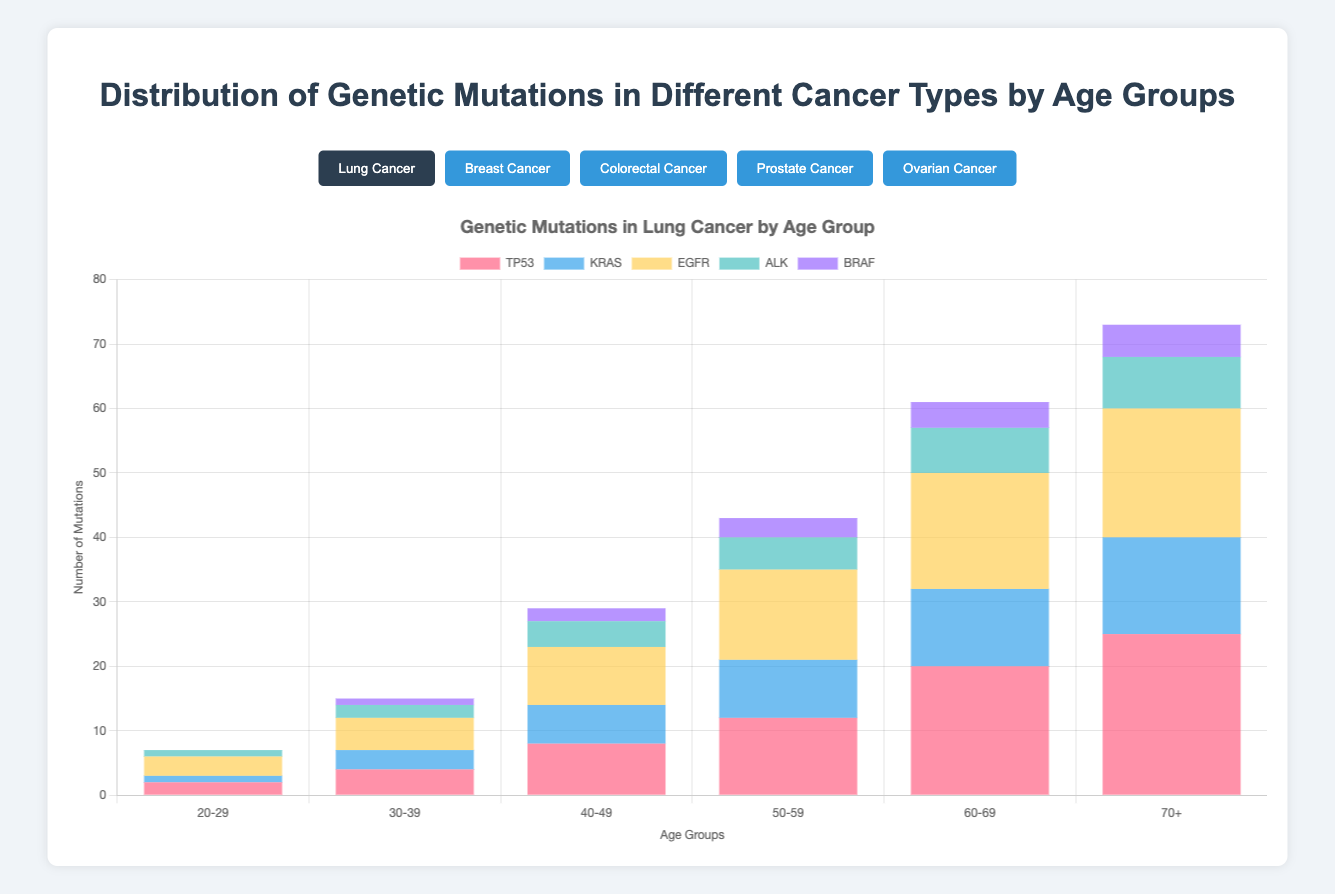Which age group experiences the highest number of TP53 mutations in Lung Cancer? Look at the stacked bar chart for Lung Cancer and identify the age group with the tallest section representing TP53 mutations. The "70+" age group has the highest section for TP53.
Answer: 70+ Which genetic mutation is least common in Breast Cancer for the 20-29 age group? Examine the stacked bar for the 20-29 age group in Breast Cancer. The smallest section in the bar is for PTEN with only 1 mutation.
Answer: PTEN Comparing KRAS mutations in Lung Cancer, which age group has a greater count: 60-69 or 50-59? Check the heights of the KRAS mutation parts of the bars for both the 60-69 and 50-59 age groups in Lung Cancer. The 60-69 age group has a higher count with 12 mutations compared to 9 in the 50-59 age group.
Answer: 60-69 What is the total number of BRCA1 mutations across all age groups in Ovarian Cancer? Sum up the BRCA1 values across all age groups in Ovarian Cancer: 5 + 8 + 11 + 15 + 18 + 20 = 77.
Answer: 77 Which cancer type shows the highest number of TP53 mutations in the 60-69 age group? Compare the TP53 sections of the 60-69 bars across all cancer types. Lung Cancer has 20, Breast Cancer has 8, Colorectal Cancer has 16, Prostate Cancer has 12, and Ovarian Cancer has 12. Lung Cancer shows the highest with 20 mutations.
Answer: Lung Cancer How do the total number of mutations for the 50-59 age group compare between Prostate Cancer and Colorectal Cancer? Sum the mutation counts for Prostate Cancer and Colorectal Cancer in the 50-59 age group. Prostate Cancer has 9 + 5 + 3 + 3 + 2 = 22, and Colorectal Cancer has 14 + 10 + 12 + 6 + 3 = 45.
Answer: Colorectal Cancer has more What is the average number of mutations for PIK3CA in the 30-39 age group across all cancer types? Find the PIK3CA counts for each cancer type in the 30-39 age group, then calculate the average: [Lung Cancer: 0 + Breast Cancer: 3 + Colorectal Cancer: 1 + Prostate Cancer: 0 + Ovarian Cancer: 1] = 5. Average = 5/5.
Answer: 1 In Breast Cancer, which age group has the greatest variety of different genetic mutations? Each bar represents genetic mutations for age groups in Breast Cancer. The 50-59 and 60-69 age groups have sections for BRCA1, BRCA2, PIK3CA, TP53, and PTEN, showing the highest variety.
Answer: 50-59 and 60-69 Which mutation in Colorectal Cancer sees the greatest increase in cases from the 40-49 to the 50-59 age group? Subtract the mutation counts in the 40-49 age group from the 50-59 age group for each gene: APC: 14-10=4, KRAS: 10-7=3, TP53: 12-8=4, SMAD4: 6-4=2, PIK3CA: 3-2=1. APC and TP53 both increase by 4.
Answer: APC and TP53 